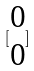Convert formula to latex. <formula><loc_0><loc_0><loc_500><loc_500>[ \begin{matrix} 0 \\ 0 \end{matrix} ]</formula> 